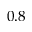Convert formula to latex. <formula><loc_0><loc_0><loc_500><loc_500>0 . 8</formula> 